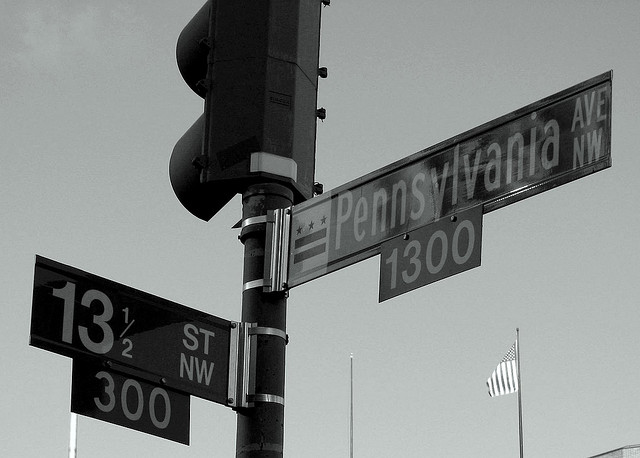Please identify all text content in this image. Pennsylvania AVE NW 1300 NW ST 13 1/2 300 